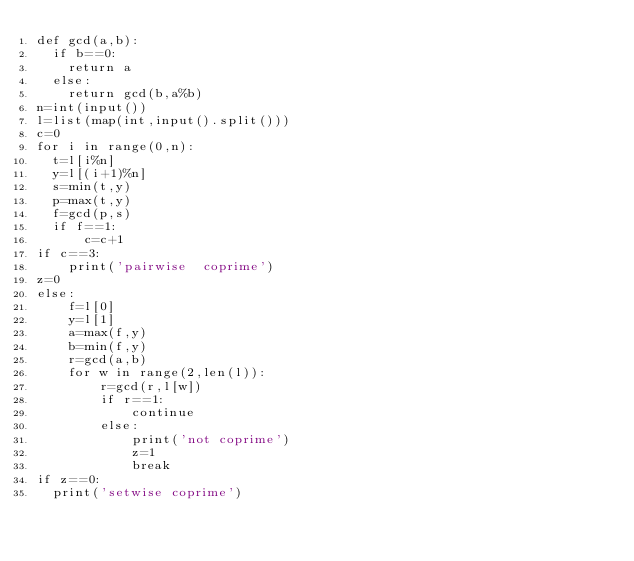<code> <loc_0><loc_0><loc_500><loc_500><_Python_>def gcd(a,b):
  if b==0:
    return a
  else:
    return gcd(b,a%b)
n=int(input())
l=list(map(int,input().split())) 
c=0
for i in range(0,n):
  t=l[i%n]
  y=l[(i+1)%n]
  s=min(t,y)
  p=max(t,y)
  f=gcd(p,s)
  if f==1:
      c=c+1
if c==3:
    print('pairwise  coprime')
z=0
else:
    f=l[0]
    y=l[1]
    a=max(f,y)
    b=min(f,y)
    r=gcd(a,b)
    for w in range(2,len(l)):
        r=gcd(r,l[w])
    	if r==1:
        	continue
    	else:
        	print('not coprime')
            z=1
            break
if z==0:
  print('setwise coprime')
</code> 